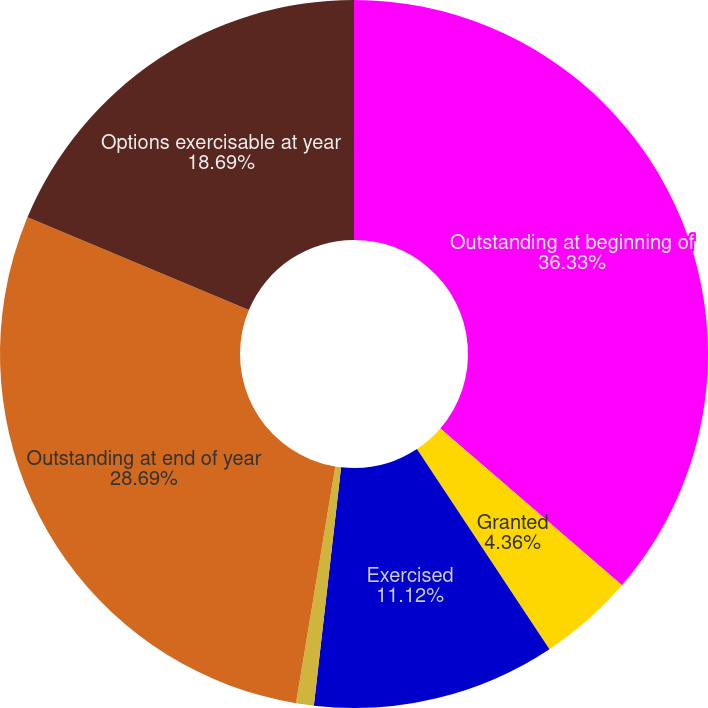Convert chart to OTSL. <chart><loc_0><loc_0><loc_500><loc_500><pie_chart><fcel>Outstanding at beginning of<fcel>Granted<fcel>Exercised<fcel>Forfeited and canceled<fcel>Outstanding at end of year<fcel>Options exercisable at year<nl><fcel>36.33%<fcel>4.36%<fcel>11.12%<fcel>0.81%<fcel>28.69%<fcel>18.69%<nl></chart> 